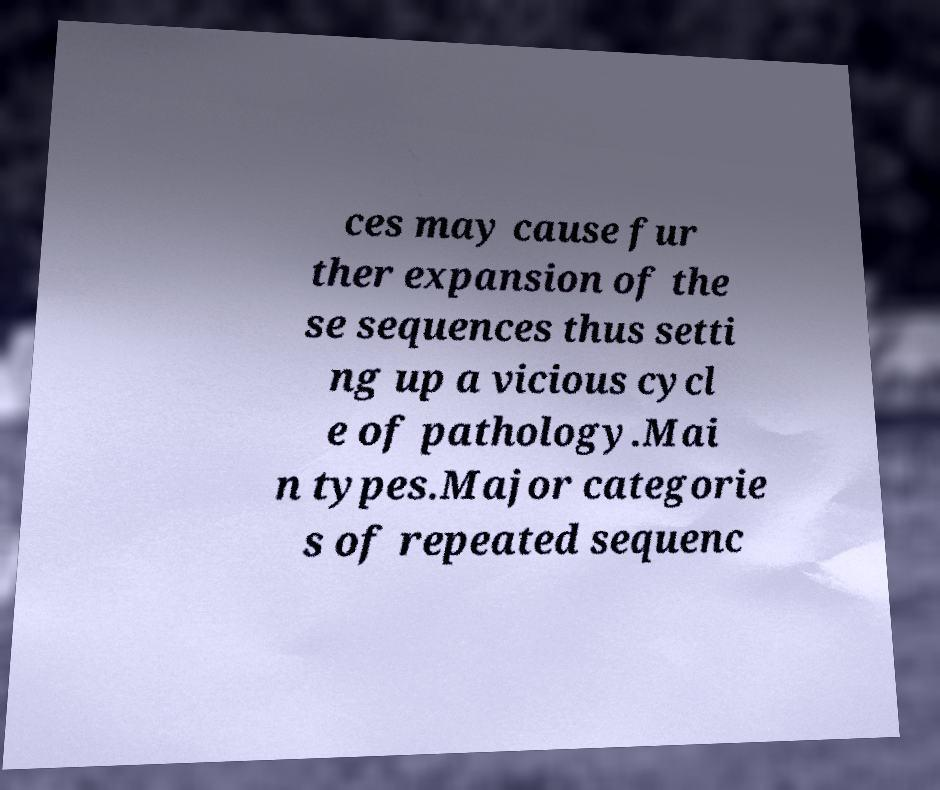Can you accurately transcribe the text from the provided image for me? ces may cause fur ther expansion of the se sequences thus setti ng up a vicious cycl e of pathology.Mai n types.Major categorie s of repeated sequenc 